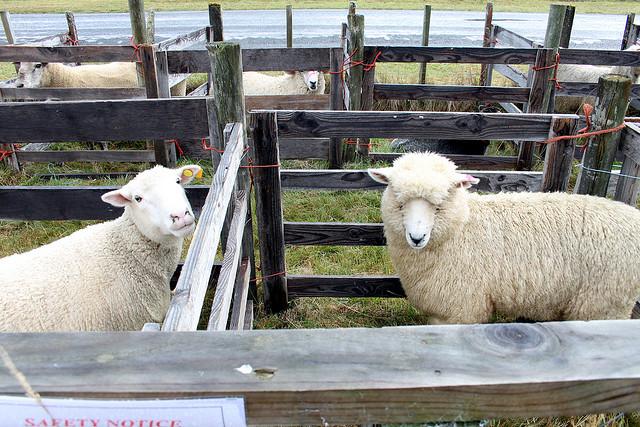What type of animal is this?
Give a very brief answer. Sheep. What does the sign say?
Concise answer only. Safety notice. How many sheep are there?
Be succinct. 4. 